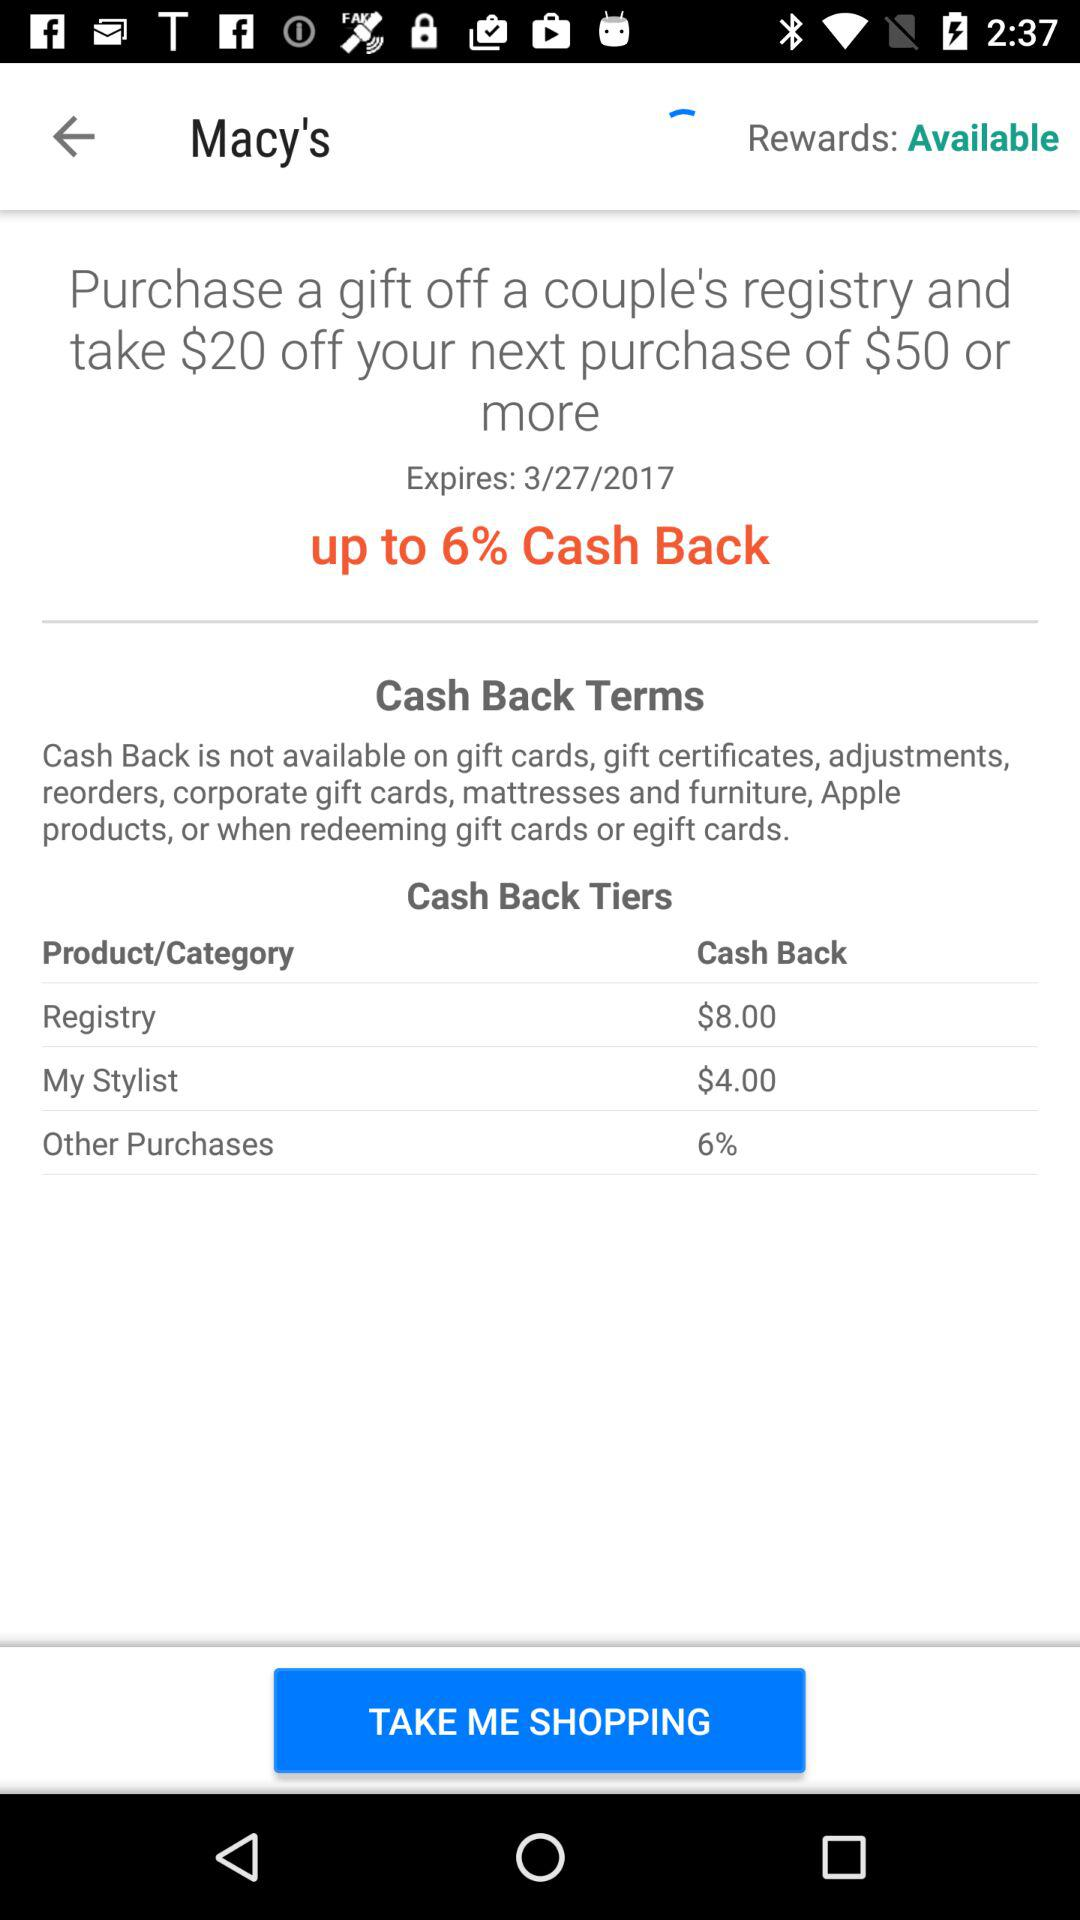How much cashback will we get on the "Registry"? You will get a cashback of $8.00 on the "Registry". 